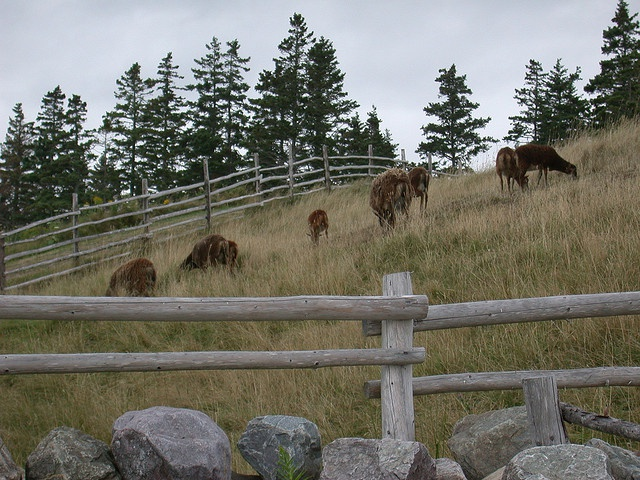Describe the objects in this image and their specific colors. I can see cow in lightgray, black, and gray tones, cow in lightgray, black, and gray tones, sheep in lightgray, black, gray, and maroon tones, cow in lightgray, black, and gray tones, and sheep in lightgray, black, and gray tones in this image. 